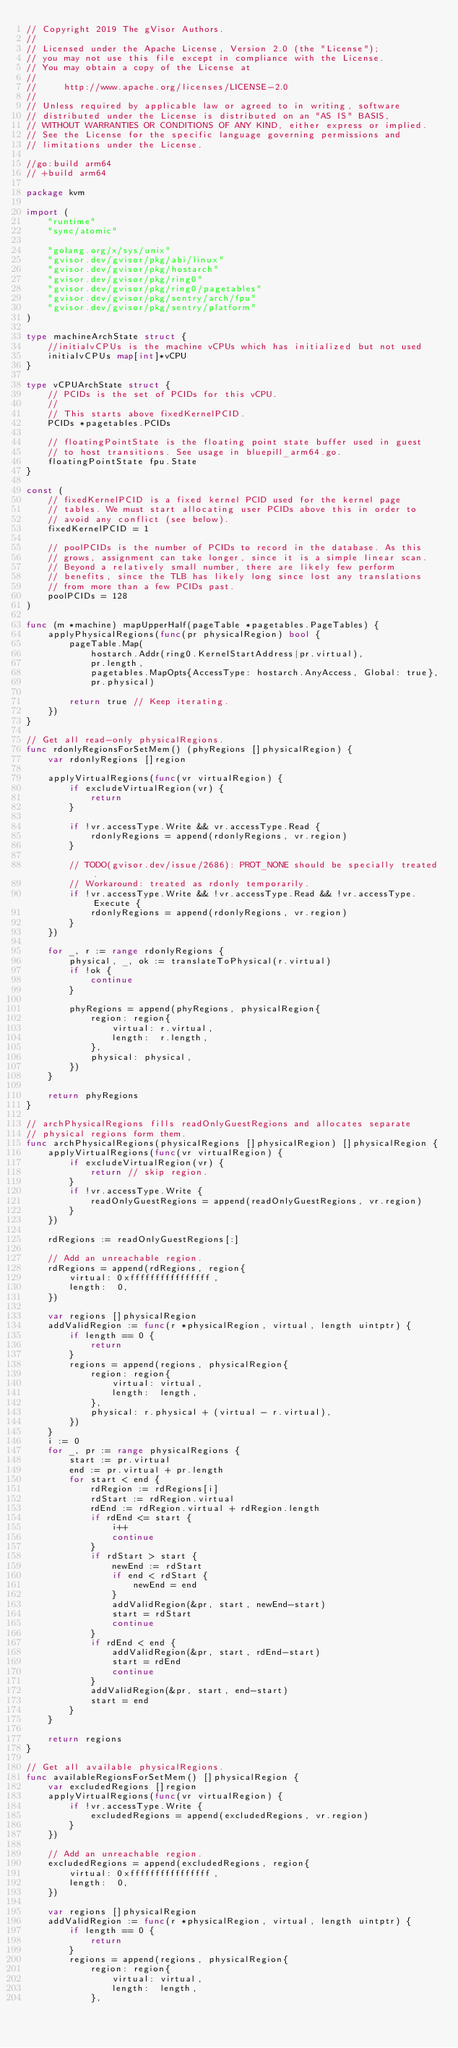Convert code to text. <code><loc_0><loc_0><loc_500><loc_500><_Go_>// Copyright 2019 The gVisor Authors.
//
// Licensed under the Apache License, Version 2.0 (the "License");
// you may not use this file except in compliance with the License.
// You may obtain a copy of the License at
//
//     http://www.apache.org/licenses/LICENSE-2.0
//
// Unless required by applicable law or agreed to in writing, software
// distributed under the License is distributed on an "AS IS" BASIS,
// WITHOUT WARRANTIES OR CONDITIONS OF ANY KIND, either express or implied.
// See the License for the specific language governing permissions and
// limitations under the License.

//go:build arm64
// +build arm64

package kvm

import (
	"runtime"
	"sync/atomic"

	"golang.org/x/sys/unix"
	"gvisor.dev/gvisor/pkg/abi/linux"
	"gvisor.dev/gvisor/pkg/hostarch"
	"gvisor.dev/gvisor/pkg/ring0"
	"gvisor.dev/gvisor/pkg/ring0/pagetables"
	"gvisor.dev/gvisor/pkg/sentry/arch/fpu"
	"gvisor.dev/gvisor/pkg/sentry/platform"
)

type machineArchState struct {
	//initialvCPUs is the machine vCPUs which has initialized but not used
	initialvCPUs map[int]*vCPU
}

type vCPUArchState struct {
	// PCIDs is the set of PCIDs for this vCPU.
	//
	// This starts above fixedKernelPCID.
	PCIDs *pagetables.PCIDs

	// floatingPointState is the floating point state buffer used in guest
	// to host transitions. See usage in bluepill_arm64.go.
	floatingPointState fpu.State
}

const (
	// fixedKernelPCID is a fixed kernel PCID used for the kernel page
	// tables. We must start allocating user PCIDs above this in order to
	// avoid any conflict (see below).
	fixedKernelPCID = 1

	// poolPCIDs is the number of PCIDs to record in the database. As this
	// grows, assignment can take longer, since it is a simple linear scan.
	// Beyond a relatively small number, there are likely few perform
	// benefits, since the TLB has likely long since lost any translations
	// from more than a few PCIDs past.
	poolPCIDs = 128
)

func (m *machine) mapUpperHalf(pageTable *pagetables.PageTables) {
	applyPhysicalRegions(func(pr physicalRegion) bool {
		pageTable.Map(
			hostarch.Addr(ring0.KernelStartAddress|pr.virtual),
			pr.length,
			pagetables.MapOpts{AccessType: hostarch.AnyAccess, Global: true},
			pr.physical)

		return true // Keep iterating.
	})
}

// Get all read-only physicalRegions.
func rdonlyRegionsForSetMem() (phyRegions []physicalRegion) {
	var rdonlyRegions []region

	applyVirtualRegions(func(vr virtualRegion) {
		if excludeVirtualRegion(vr) {
			return
		}

		if !vr.accessType.Write && vr.accessType.Read {
			rdonlyRegions = append(rdonlyRegions, vr.region)
		}

		// TODO(gvisor.dev/issue/2686): PROT_NONE should be specially treated.
		// Workaround: treated as rdonly temporarily.
		if !vr.accessType.Write && !vr.accessType.Read && !vr.accessType.Execute {
			rdonlyRegions = append(rdonlyRegions, vr.region)
		}
	})

	for _, r := range rdonlyRegions {
		physical, _, ok := translateToPhysical(r.virtual)
		if !ok {
			continue
		}

		phyRegions = append(phyRegions, physicalRegion{
			region: region{
				virtual: r.virtual,
				length:  r.length,
			},
			physical: physical,
		})
	}

	return phyRegions
}

// archPhysicalRegions fills readOnlyGuestRegions and allocates separate
// physical regions form them.
func archPhysicalRegions(physicalRegions []physicalRegion) []physicalRegion {
	applyVirtualRegions(func(vr virtualRegion) {
		if excludeVirtualRegion(vr) {
			return // skip region.
		}
		if !vr.accessType.Write {
			readOnlyGuestRegions = append(readOnlyGuestRegions, vr.region)
		}
	})

	rdRegions := readOnlyGuestRegions[:]

	// Add an unreachable region.
	rdRegions = append(rdRegions, region{
		virtual: 0xffffffffffffffff,
		length:  0,
	})

	var regions []physicalRegion
	addValidRegion := func(r *physicalRegion, virtual, length uintptr) {
		if length == 0 {
			return
		}
		regions = append(regions, physicalRegion{
			region: region{
				virtual: virtual,
				length:  length,
			},
			physical: r.physical + (virtual - r.virtual),
		})
	}
	i := 0
	for _, pr := range physicalRegions {
		start := pr.virtual
		end := pr.virtual + pr.length
		for start < end {
			rdRegion := rdRegions[i]
			rdStart := rdRegion.virtual
			rdEnd := rdRegion.virtual + rdRegion.length
			if rdEnd <= start {
				i++
				continue
			}
			if rdStart > start {
				newEnd := rdStart
				if end < rdStart {
					newEnd = end
				}
				addValidRegion(&pr, start, newEnd-start)
				start = rdStart
				continue
			}
			if rdEnd < end {
				addValidRegion(&pr, start, rdEnd-start)
				start = rdEnd
				continue
			}
			addValidRegion(&pr, start, end-start)
			start = end
		}
	}

	return regions
}

// Get all available physicalRegions.
func availableRegionsForSetMem() []physicalRegion {
	var excludedRegions []region
	applyVirtualRegions(func(vr virtualRegion) {
		if !vr.accessType.Write {
			excludedRegions = append(excludedRegions, vr.region)
		}
	})

	// Add an unreachable region.
	excludedRegions = append(excludedRegions, region{
		virtual: 0xffffffffffffffff,
		length:  0,
	})

	var regions []physicalRegion
	addValidRegion := func(r *physicalRegion, virtual, length uintptr) {
		if length == 0 {
			return
		}
		regions = append(regions, physicalRegion{
			region: region{
				virtual: virtual,
				length:  length,
			},</code> 